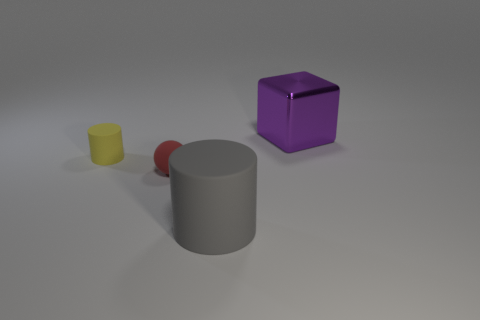Add 1 tiny blue rubber cylinders. How many objects exist? 5 Subtract all balls. How many objects are left? 3 Subtract 0 purple cylinders. How many objects are left? 4 Subtract all big objects. Subtract all small matte spheres. How many objects are left? 1 Add 1 large shiny blocks. How many large shiny blocks are left? 2 Add 3 green objects. How many green objects exist? 3 